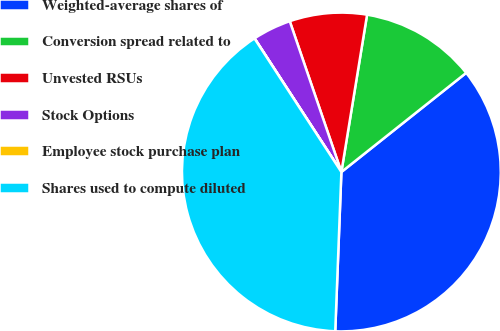Convert chart. <chart><loc_0><loc_0><loc_500><loc_500><pie_chart><fcel>Weighted-average shares of<fcel>Conversion spread related to<fcel>Unvested RSUs<fcel>Stock Options<fcel>Employee stock purchase plan<fcel>Shares used to compute diluted<nl><fcel>36.3%<fcel>11.74%<fcel>7.83%<fcel>3.92%<fcel>0.01%<fcel>40.21%<nl></chart> 